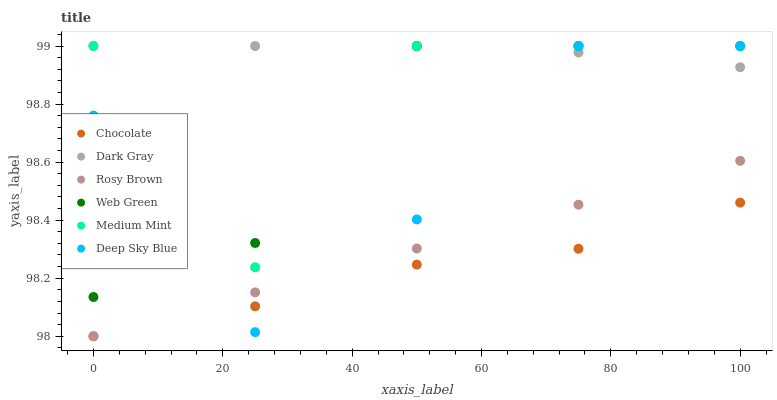Does Chocolate have the minimum area under the curve?
Answer yes or no. Yes. Does Dark Gray have the maximum area under the curve?
Answer yes or no. Yes. Does Rosy Brown have the minimum area under the curve?
Answer yes or no. No. Does Rosy Brown have the maximum area under the curve?
Answer yes or no. No. Is Rosy Brown the smoothest?
Answer yes or no. Yes. Is Medium Mint the roughest?
Answer yes or no. Yes. Is Web Green the smoothest?
Answer yes or no. No. Is Web Green the roughest?
Answer yes or no. No. Does Rosy Brown have the lowest value?
Answer yes or no. Yes. Does Web Green have the lowest value?
Answer yes or no. No. Does Deep Sky Blue have the highest value?
Answer yes or no. Yes. Does Rosy Brown have the highest value?
Answer yes or no. No. Is Rosy Brown less than Web Green?
Answer yes or no. Yes. Is Web Green greater than Rosy Brown?
Answer yes or no. Yes. Does Medium Mint intersect Web Green?
Answer yes or no. Yes. Is Medium Mint less than Web Green?
Answer yes or no. No. Is Medium Mint greater than Web Green?
Answer yes or no. No. Does Rosy Brown intersect Web Green?
Answer yes or no. No. 